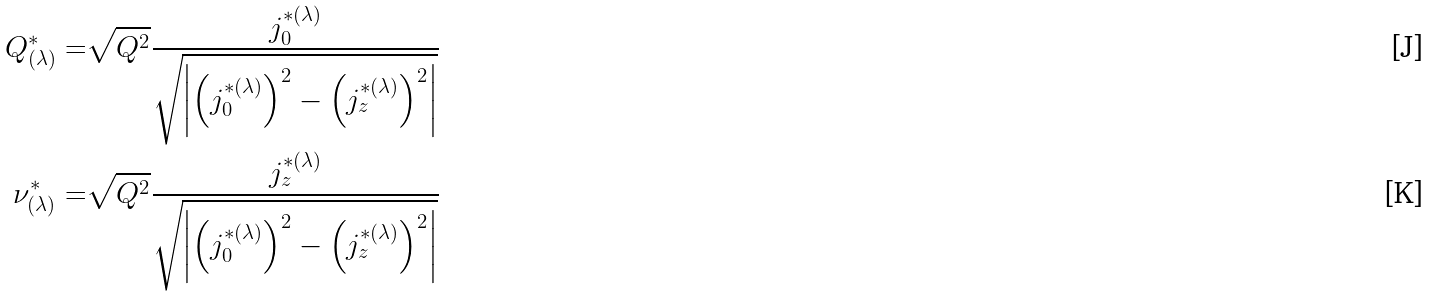<formula> <loc_0><loc_0><loc_500><loc_500>Q _ { ( \lambda ) } ^ { * } = & \sqrt { Q ^ { 2 } } \frac { j _ { 0 } ^ { * ( \lambda ) } } { \sqrt { \left | \left ( j _ { 0 } ^ { * ( \lambda ) } \right ) ^ { 2 } - \left ( j _ { z } ^ { * ( \lambda ) } \right ) ^ { 2 } \right | } } \\ \nu _ { ( \lambda ) } ^ { * } = & \sqrt { Q ^ { 2 } } \frac { j _ { z } ^ { * ( \lambda ) } } { \sqrt { \left | \left ( j _ { 0 } ^ { * ( \lambda ) } \right ) ^ { 2 } - \left ( j _ { z } ^ { * ( \lambda ) } \right ) ^ { 2 } \right | } }</formula> 